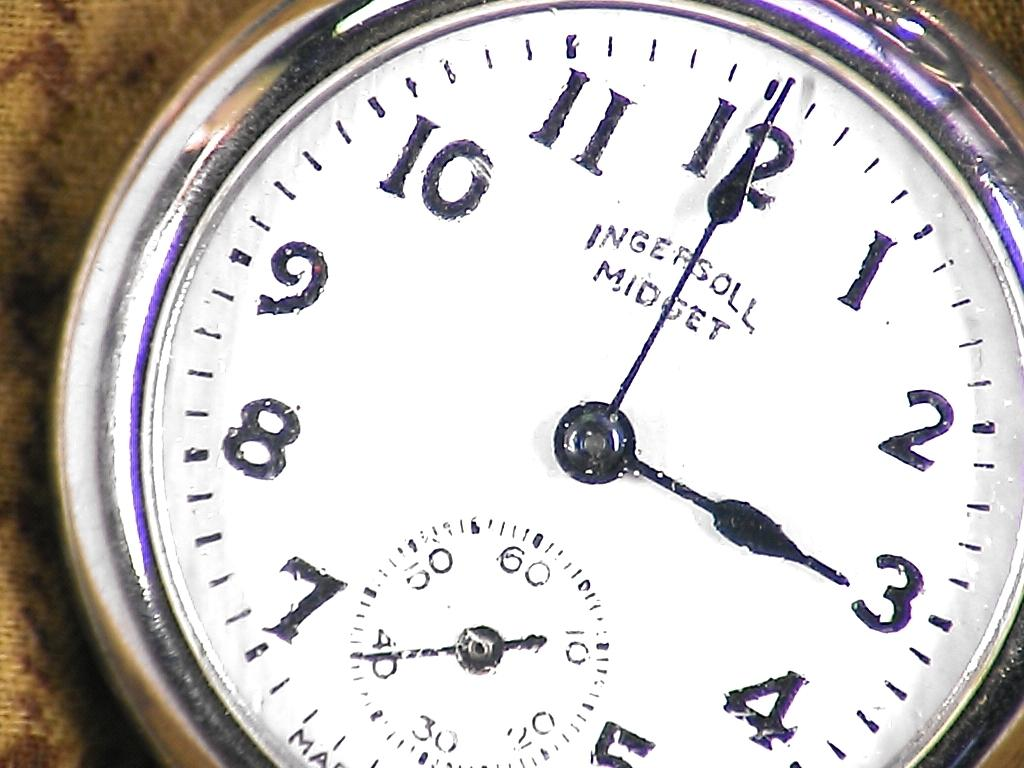Provide a one-sentence caption for the provided image. the numbers 1 to 12 that are on a clock. 